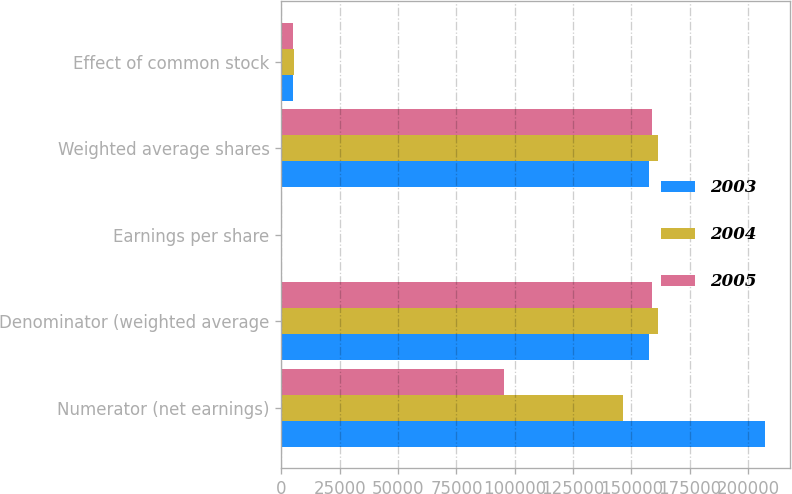Convert chart. <chart><loc_0><loc_0><loc_500><loc_500><stacked_bar_chart><ecel><fcel>Numerator (net earnings)<fcel>Denominator (weighted average<fcel>Earnings per share<fcel>Weighted average shares<fcel>Effect of common stock<nl><fcel>2003<fcel>207311<fcel>157583<fcel>1.32<fcel>157583<fcel>4976<nl><fcel>2004<fcel>146256<fcel>161542<fcel>0.91<fcel>161542<fcel>5395<nl><fcel>2005<fcel>95459<fcel>158800<fcel>0.6<fcel>158800<fcel>4908<nl></chart> 